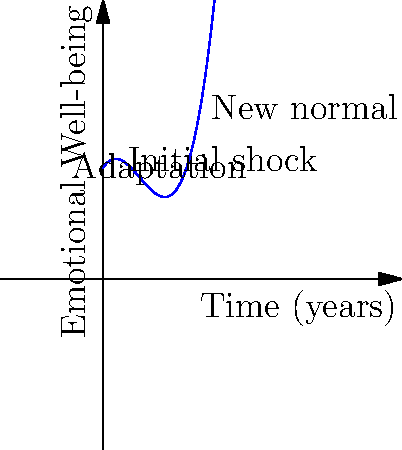The graph represents the emotional well-being trajectory of parents raising a child with a rare genetic disorder over time. Based on the curve, at which point does the emotional well-being start to show consistent improvement? To determine when the emotional well-being starts to show consistent improvement, we need to analyze the curve:

1. The curve starts high, representing the initial period before diagnosis.
2. It then drops sharply, indicating the shock and distress upon receiving the diagnosis.
3. The lowest point of the curve represents the period of greatest struggle and adjustment.
4. After this lowest point, the curve begins to rise again.
5. The point where the curve changes from decreasing to increasing (the local minimum) is where emotional well-being starts to consistently improve.
6. This point occurs at approximately the 2-year mark on the time axis.
7. After this point, the curve continues to rise, showing ongoing improvement in emotional well-being as parents adapt and find a "new normal."

Therefore, the emotional well-being starts to show consistent improvement at around the 2-year mark after the initial diagnosis or recognition of the child's rare genetic disorder.
Answer: At approximately 2 years 